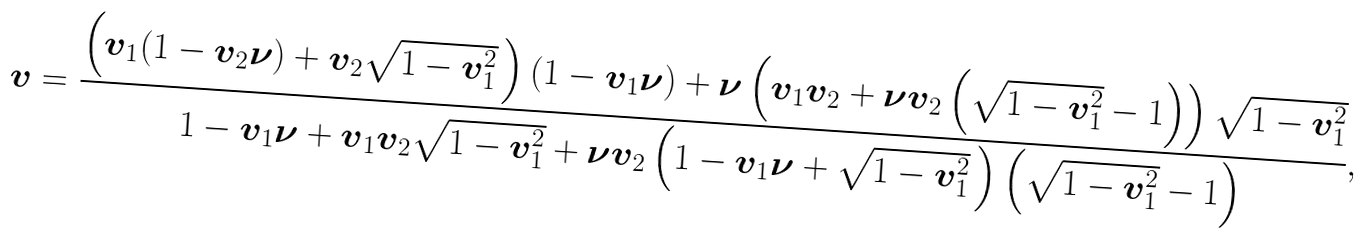<formula> <loc_0><loc_0><loc_500><loc_500>\boldsymbol v = \frac { \left ( { \boldsymbol v } _ { 1 } ( 1 - { \boldsymbol v } _ { 2 } \boldsymbol \nu ) + { \boldsymbol v } _ { 2 } \sqrt { 1 - { \boldsymbol v } _ { 1 } ^ { 2 } } \, \right ) ( 1 - { \boldsymbol v } _ { 1 } \boldsymbol \nu ) + \boldsymbol \nu \left ( { \boldsymbol v } _ { 1 } { \boldsymbol v } _ { 2 } + \boldsymbol \nu { \boldsymbol v } _ { 2 } \left ( \sqrt { 1 - { \boldsymbol v } _ { 1 } ^ { 2 } } - 1 \right ) \right ) \sqrt { 1 - { \boldsymbol v } _ { 1 } ^ { 2 } } } { 1 - { \boldsymbol v } _ { 1 } \boldsymbol \nu + { \boldsymbol v } _ { 1 } { \boldsymbol v } _ { 2 } \sqrt { 1 - { \boldsymbol v } _ { 1 } ^ { 2 } } + \boldsymbol \nu { \boldsymbol v } _ { 2 } \left ( 1 - { \boldsymbol v } _ { 1 } \boldsymbol \nu + \sqrt { 1 - { \boldsymbol v } _ { 1 } ^ { 2 } } \, \right ) \left ( \sqrt { 1 - { \boldsymbol v } _ { 1 } ^ { 2 } } - 1 \right ) } , \,</formula> 